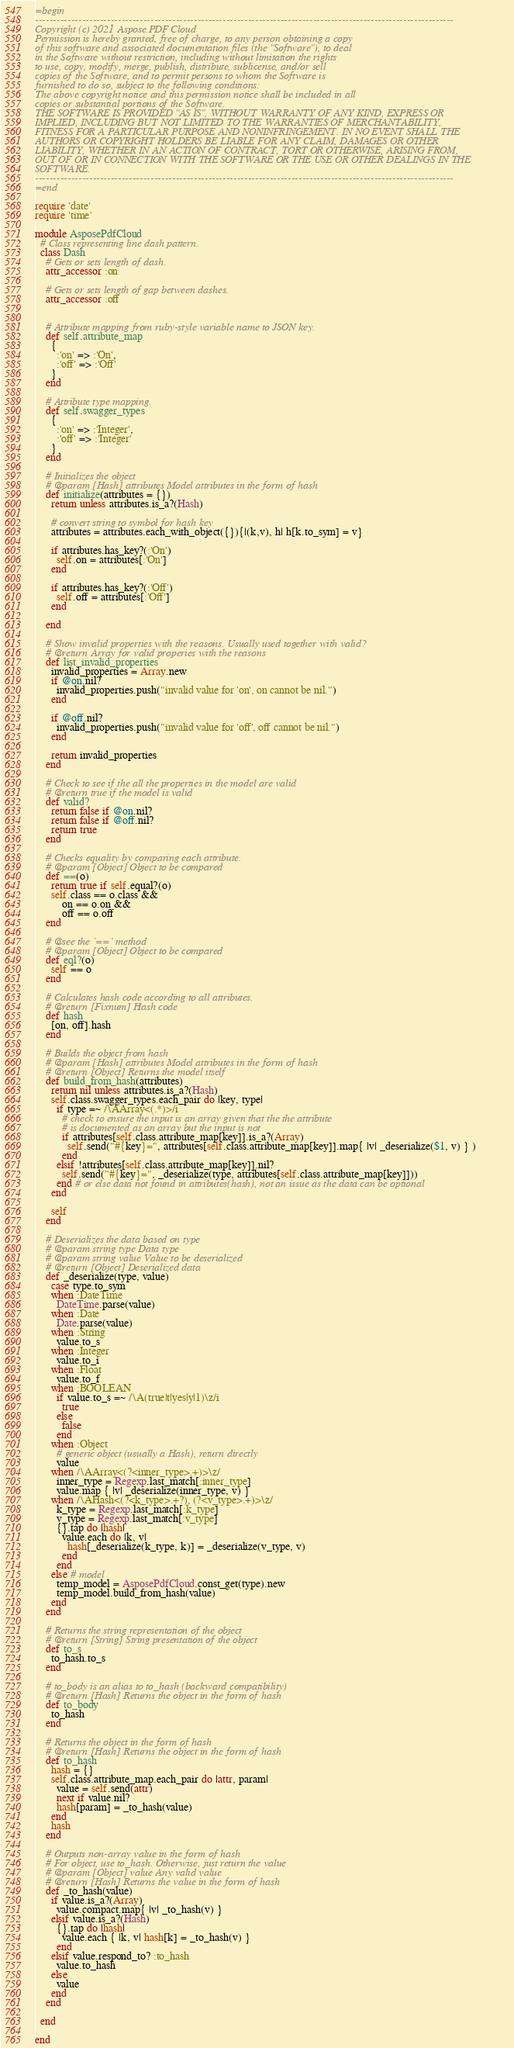<code> <loc_0><loc_0><loc_500><loc_500><_Ruby_>=begin
--------------------------------------------------------------------------------------------------------------------
Copyright (c) 2021 Aspose.PDF Cloud
Permission is hereby granted, free of charge, to any person obtaining a copy
of this software and associated documentation files (the "Software"), to deal
in the Software without restriction, including without limitation the rights
to use, copy, modify, merge, publish, distribute, sublicense, and/or sell
copies of the Software, and to permit persons to whom the Software is
furnished to do so, subject to the following conditions:
The above copyright notice and this permission notice shall be included in all
copies or substantial portions of the Software.
THE SOFTWARE IS PROVIDED "AS IS", WITHOUT WARRANTY OF ANY KIND, EXPRESS OR
IMPLIED, INCLUDING BUT NOT LIMITED TO THE WARRANTIES OF MERCHANTABILITY,
FITNESS FOR A PARTICULAR PURPOSE AND NONINFRINGEMENT. IN NO EVENT SHALL THE
AUTHORS OR COPYRIGHT HOLDERS BE LIABLE FOR ANY CLAIM, DAMAGES OR OTHER
LIABILITY, WHETHER IN AN ACTION OF CONTRACT, TORT OR OTHERWISE, ARISING FROM,
OUT OF OR IN CONNECTION WITH THE SOFTWARE OR THE USE OR OTHER DEALINGS IN THE
SOFTWARE.
--------------------------------------------------------------------------------------------------------------------
=end

require 'date'
require 'time'

module AsposePdfCloud
  # Class representing line dash pattern.
  class Dash
    # Gets or sets length of dash.
    attr_accessor :on

    # Gets or sets length of gap between dashes.
    attr_accessor :off


    # Attribute mapping from ruby-style variable name to JSON key.
    def self.attribute_map
      {
        :'on' => :'On',
        :'off' => :'Off'
      }
    end

    # Attribute type mapping.
    def self.swagger_types
      {
        :'on' => :'Integer',
        :'off' => :'Integer'
      }
    end

    # Initializes the object
    # @param [Hash] attributes Model attributes in the form of hash
    def initialize(attributes = {})
      return unless attributes.is_a?(Hash)

      # convert string to symbol for hash key
      attributes = attributes.each_with_object({}){|(k,v), h| h[k.to_sym] = v}

      if attributes.has_key?(:'On')
        self.on = attributes[:'On']
      end

      if attributes.has_key?(:'Off')
        self.off = attributes[:'Off']
      end

    end

    # Show invalid properties with the reasons. Usually used together with valid?
    # @return Array for valid properies with the reasons
    def list_invalid_properties
      invalid_properties = Array.new
      if @on.nil?
        invalid_properties.push("invalid value for 'on', on cannot be nil.")
      end

      if @off.nil?
        invalid_properties.push("invalid value for 'off', off cannot be nil.")
      end

      return invalid_properties
    end

    # Check to see if the all the properties in the model are valid
    # @return true if the model is valid
    def valid?
      return false if @on.nil?
      return false if @off.nil?
      return true
    end

    # Checks equality by comparing each attribute.
    # @param [Object] Object to be compared
    def ==(o)
      return true if self.equal?(o)
      self.class == o.class &&
          on == o.on &&
          off == o.off
    end

    # @see the `==` method
    # @param [Object] Object to be compared
    def eql?(o)
      self == o
    end

    # Calculates hash code according to all attributes.
    # @return [Fixnum] Hash code
    def hash
      [on, off].hash
    end

    # Builds the object from hash
    # @param [Hash] attributes Model attributes in the form of hash
    # @return [Object] Returns the model itself
    def build_from_hash(attributes)
      return nil unless attributes.is_a?(Hash)
      self.class.swagger_types.each_pair do |key, type|
        if type =~ /\AArray<(.*)>/i
          # check to ensure the input is an array given that the the attribute
          # is documented as an array but the input is not
          if attributes[self.class.attribute_map[key]].is_a?(Array)
            self.send("#{key}=", attributes[self.class.attribute_map[key]].map{ |v| _deserialize($1, v) } )
          end
        elsif !attributes[self.class.attribute_map[key]].nil?
          self.send("#{key}=", _deserialize(type, attributes[self.class.attribute_map[key]]))
        end # or else data not found in attributes(hash), not an issue as the data can be optional
      end

      self
    end

    # Deserializes the data based on type
    # @param string type Data type
    # @param string value Value to be deserialized
    # @return [Object] Deserialized data
    def _deserialize(type, value)
      case type.to_sym
      when :DateTime
        DateTime.parse(value)
      when :Date
        Date.parse(value)
      when :String
        value.to_s
      when :Integer
        value.to_i
      when :Float
        value.to_f
      when :BOOLEAN
        if value.to_s =~ /\A(true|t|yes|y|1)\z/i
          true
        else
          false
        end
      when :Object
        # generic object (usually a Hash), return directly
        value
      when /\AArray<(?<inner_type>.+)>\z/
        inner_type = Regexp.last_match[:inner_type]
        value.map { |v| _deserialize(inner_type, v) }
      when /\AHash<(?<k_type>.+?), (?<v_type>.+)>\z/
        k_type = Regexp.last_match[:k_type]
        v_type = Regexp.last_match[:v_type]
        {}.tap do |hash|
          value.each do |k, v|
            hash[_deserialize(k_type, k)] = _deserialize(v_type, v)
          end
        end
      else # model
        temp_model = AsposePdfCloud.const_get(type).new
        temp_model.build_from_hash(value)
      end
    end

    # Returns the string representation of the object
    # @return [String] String presentation of the object
    def to_s
      to_hash.to_s
    end

    # to_body is an alias to to_hash (backward compatibility)
    # @return [Hash] Returns the object in the form of hash
    def to_body
      to_hash
    end

    # Returns the object in the form of hash
    # @return [Hash] Returns the object in the form of hash
    def to_hash
      hash = {}
      self.class.attribute_map.each_pair do |attr, param|
        value = self.send(attr)
        next if value.nil?
        hash[param] = _to_hash(value)
      end
      hash
    end

    # Outputs non-array value in the form of hash
    # For object, use to_hash. Otherwise, just return the value
    # @param [Object] value Any valid value
    # @return [Hash] Returns the value in the form of hash
    def _to_hash(value)
      if value.is_a?(Array)
        value.compact.map{ |v| _to_hash(v) }
      elsif value.is_a?(Hash)
        {}.tap do |hash|
          value.each { |k, v| hash[k] = _to_hash(v) }
        end
      elsif value.respond_to? :to_hash
        value.to_hash
      else
        value
      end
    end

  end

end
</code> 